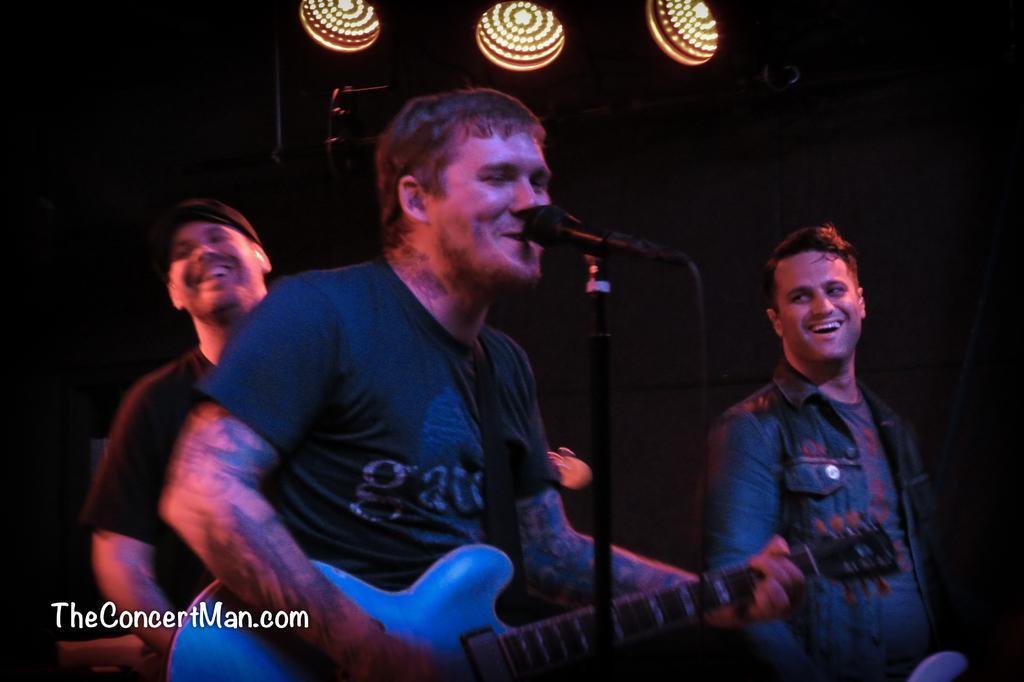Can you describe this image briefly? There are three members in the picture. All of them were smiling. The guy in the middle is playing a guitar in his hands and he is singing. There is a microphone and a stand in front of him. In the background there are some lights. 